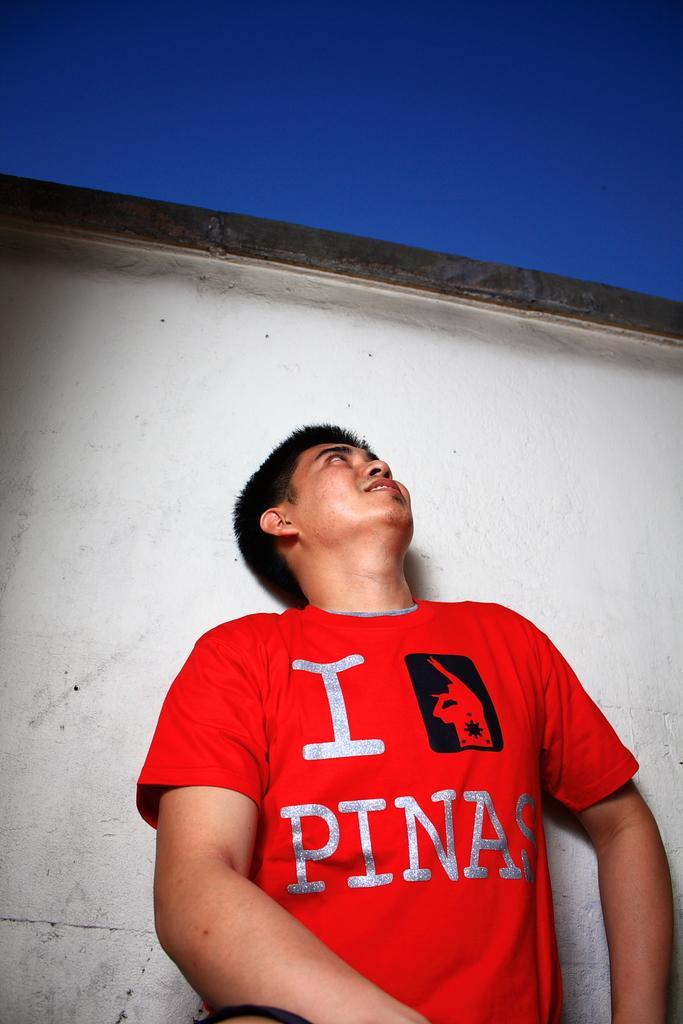Describe this image in one or two sentences. In this image there is a man standing, in the background there is a wall and the sky. 